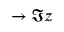<formula> <loc_0><loc_0><loc_500><loc_500>\rightarrow \Im { z }</formula> 